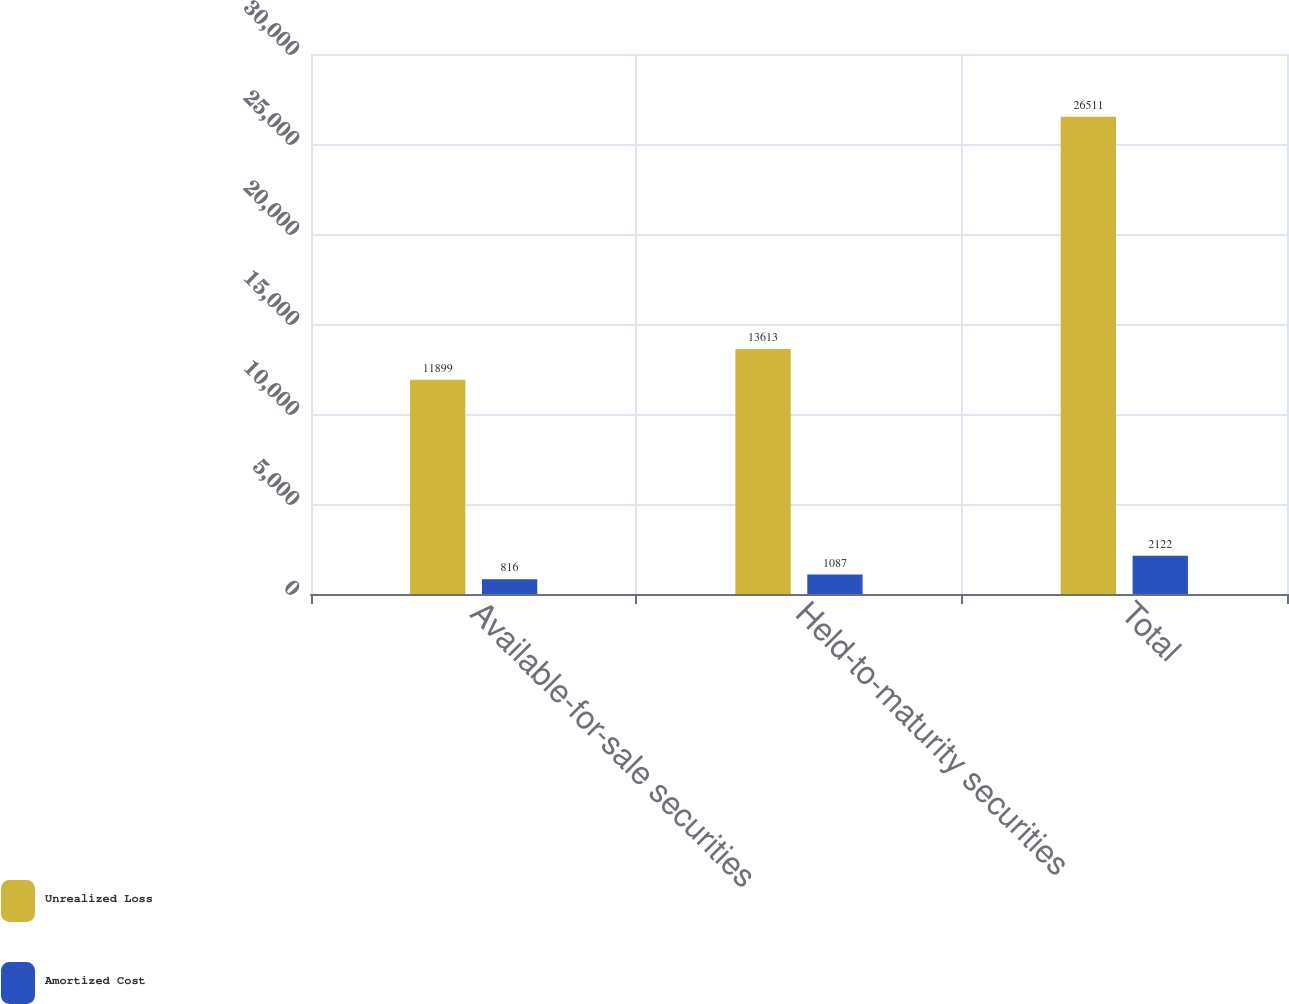Convert chart to OTSL. <chart><loc_0><loc_0><loc_500><loc_500><stacked_bar_chart><ecel><fcel>Available-for-sale securities<fcel>Held-to-maturity securities<fcel>Total<nl><fcel>Unrealized Loss<fcel>11899<fcel>13613<fcel>26511<nl><fcel>Amortized Cost<fcel>816<fcel>1087<fcel>2122<nl></chart> 